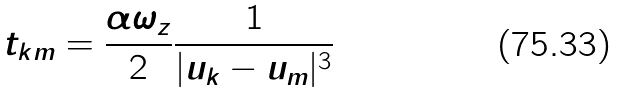Convert formula to latex. <formula><loc_0><loc_0><loc_500><loc_500>t _ { k m } = \frac { \alpha \omega _ { z } } { 2 } \frac { 1 } { | u _ { k } - u _ { m } | ^ { 3 } }</formula> 